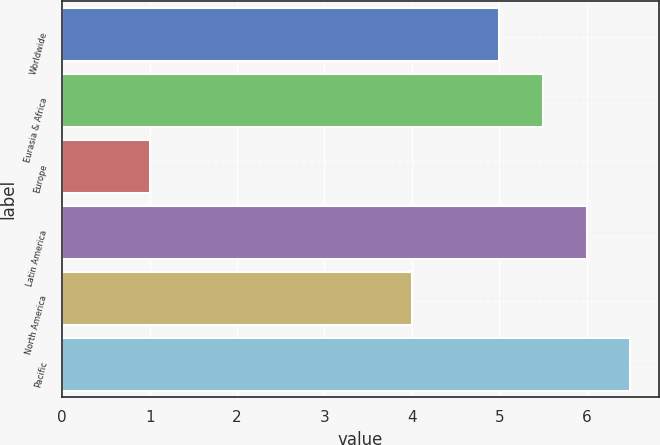<chart> <loc_0><loc_0><loc_500><loc_500><bar_chart><fcel>Worldwide<fcel>Eurasia & Africa<fcel>Europe<fcel>Latin America<fcel>North America<fcel>Pacific<nl><fcel>5<fcel>5.5<fcel>1<fcel>6<fcel>4<fcel>6.5<nl></chart> 